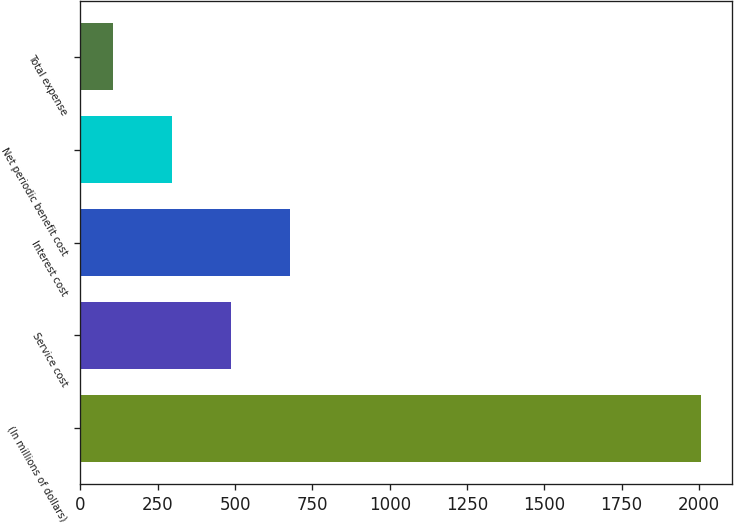Convert chart. <chart><loc_0><loc_0><loc_500><loc_500><bar_chart><fcel>(In millions of dollars)<fcel>Service cost<fcel>Interest cost<fcel>Net periodic benefit cost<fcel>Total expense<nl><fcel>2007<fcel>486.2<fcel>676.3<fcel>296.1<fcel>106<nl></chart> 